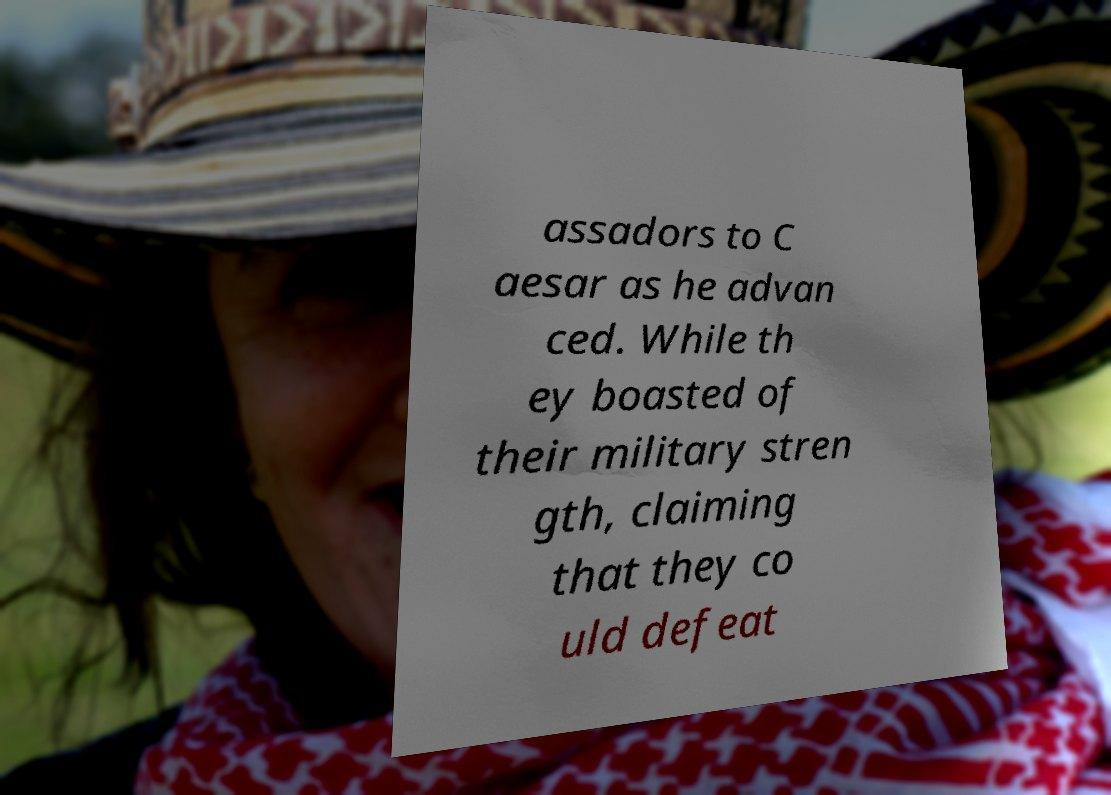Could you assist in decoding the text presented in this image and type it out clearly? assadors to C aesar as he advan ced. While th ey boasted of their military stren gth, claiming that they co uld defeat 